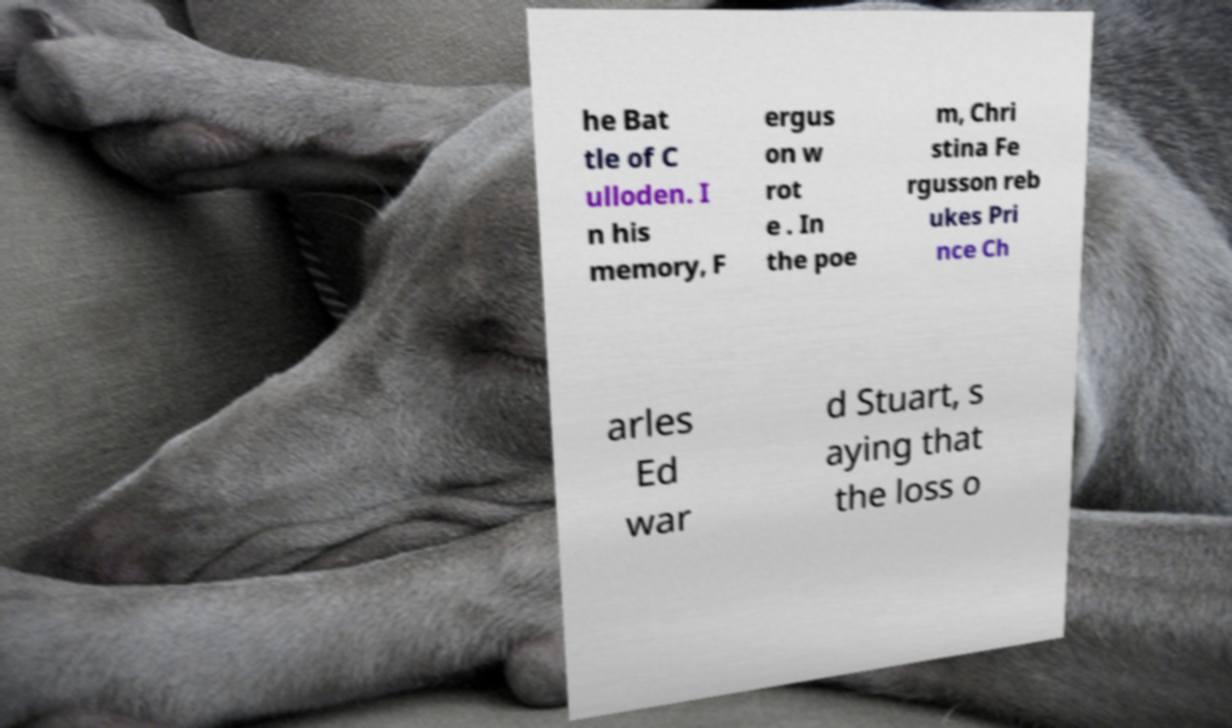For documentation purposes, I need the text within this image transcribed. Could you provide that? he Bat tle of C ulloden. I n his memory, F ergus on w rot e . In the poe m, Chri stina Fe rgusson reb ukes Pri nce Ch arles Ed war d Stuart, s aying that the loss o 